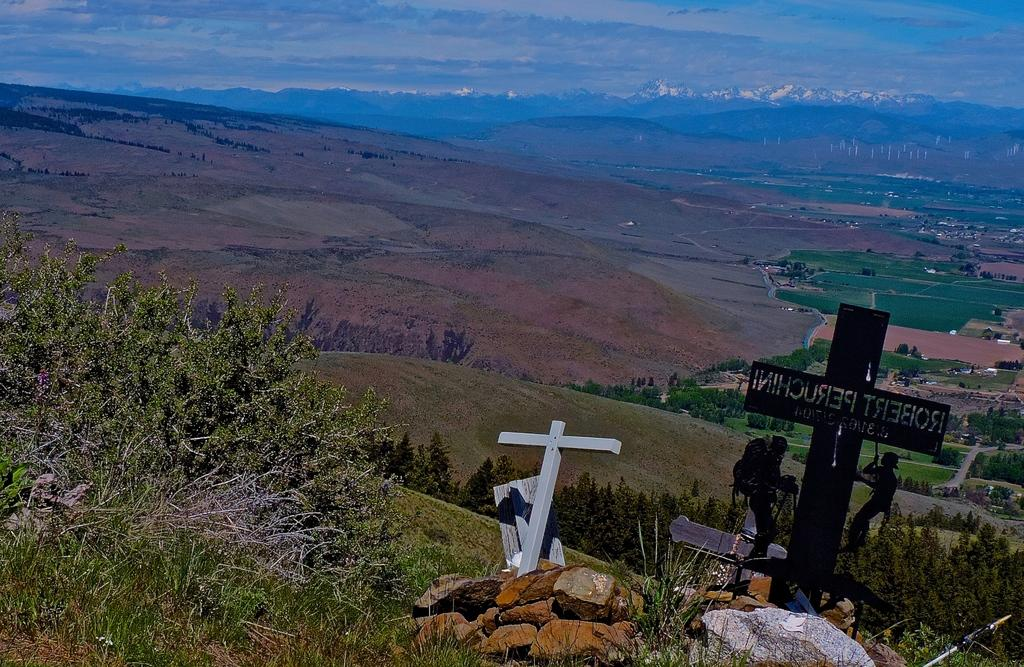What type of objects can be seen in the image? There are stones and plants in the image. Are there any symbols present in the image? Yes, there are cross symbols in the image. Can you describe the people in the image? There are people in the image, but their specific actions or characteristics are not mentioned in the provided facts. What is visible in the background of the image? There are many trees, the ground, clouds, and the sky visible in the background of the image. What type of fang can be seen in the image? There is no fang present in the image. How many carriages are visible in the image? There is no carriage present in the image. 